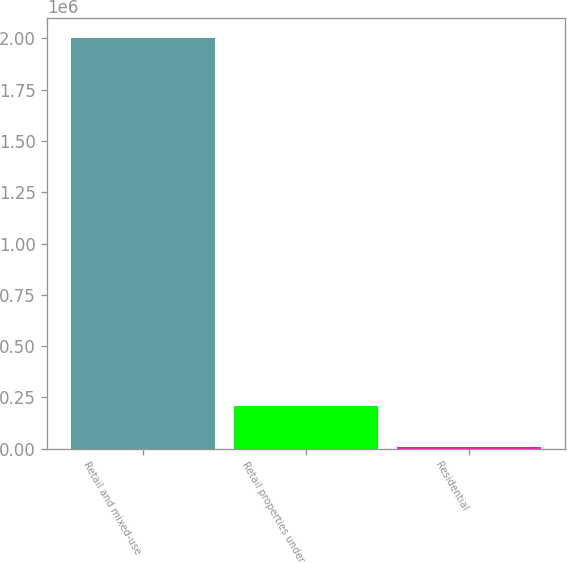<chart> <loc_0><loc_0><loc_500><loc_500><bar_chart><fcel>Retail and mixed-use<fcel>Retail properties under<fcel>Residential<nl><fcel>2.00027e+06<fcel>208715<fcel>9653<nl></chart> 